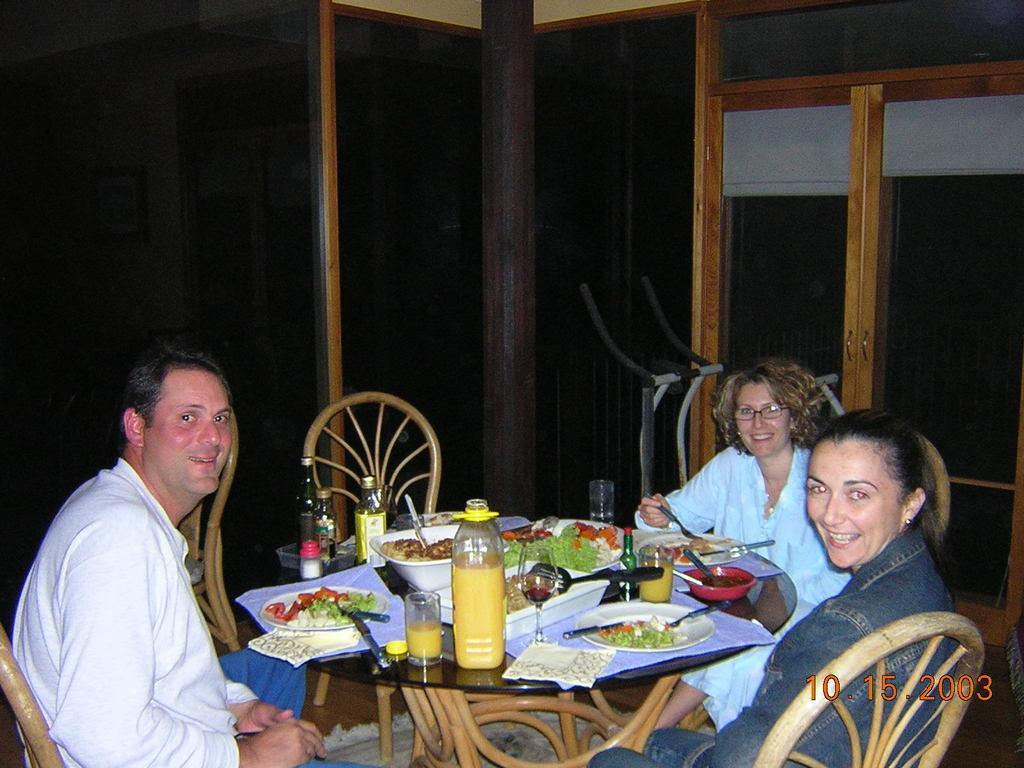In one or two sentences, can you explain what this image depicts? In the image we can see three people were sitting on the chair around the table. And on the table we can see some food items,and water bottles,glasses etc. Coming to the left corner man he is smiling which we can see on his face. And rest of the ladies were also smiling. Coming to the background there is a thread mill and pillar. 